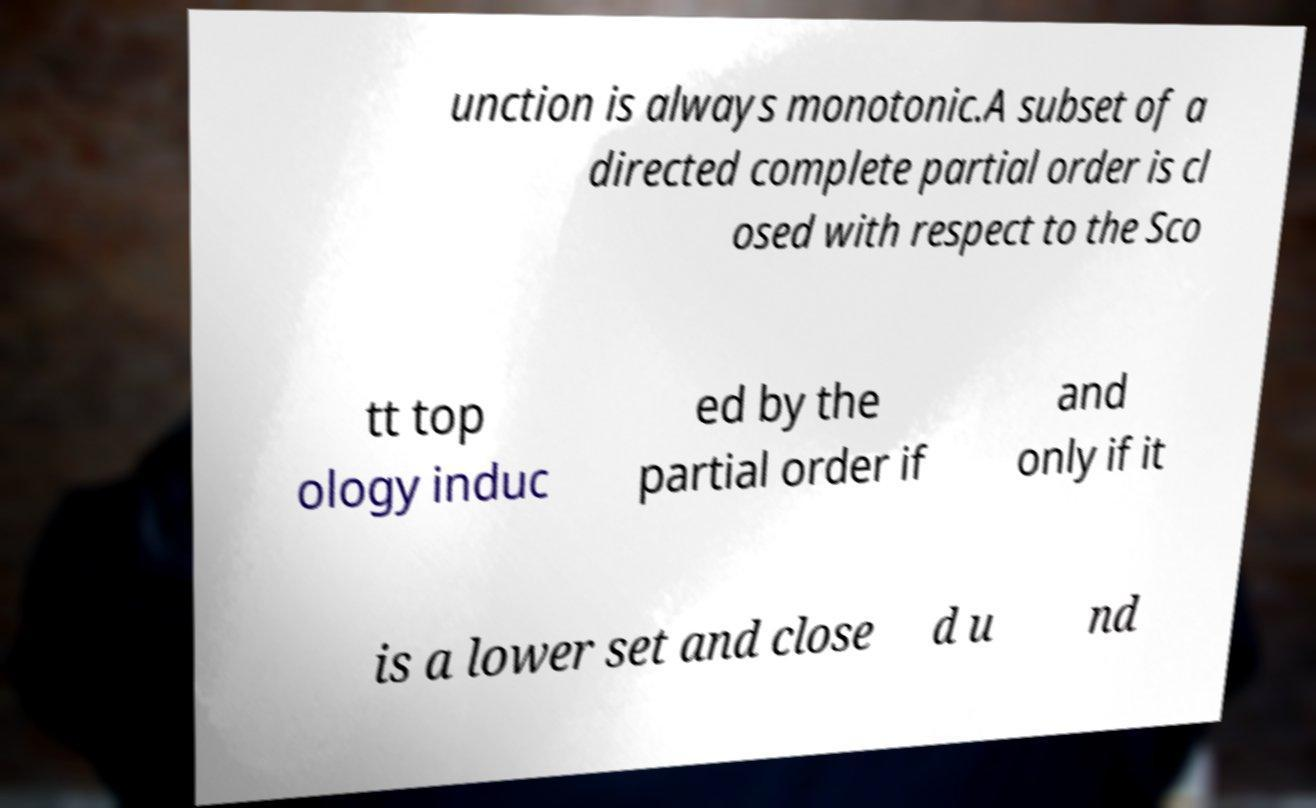Please identify and transcribe the text found in this image. unction is always monotonic.A subset of a directed complete partial order is cl osed with respect to the Sco tt top ology induc ed by the partial order if and only if it is a lower set and close d u nd 